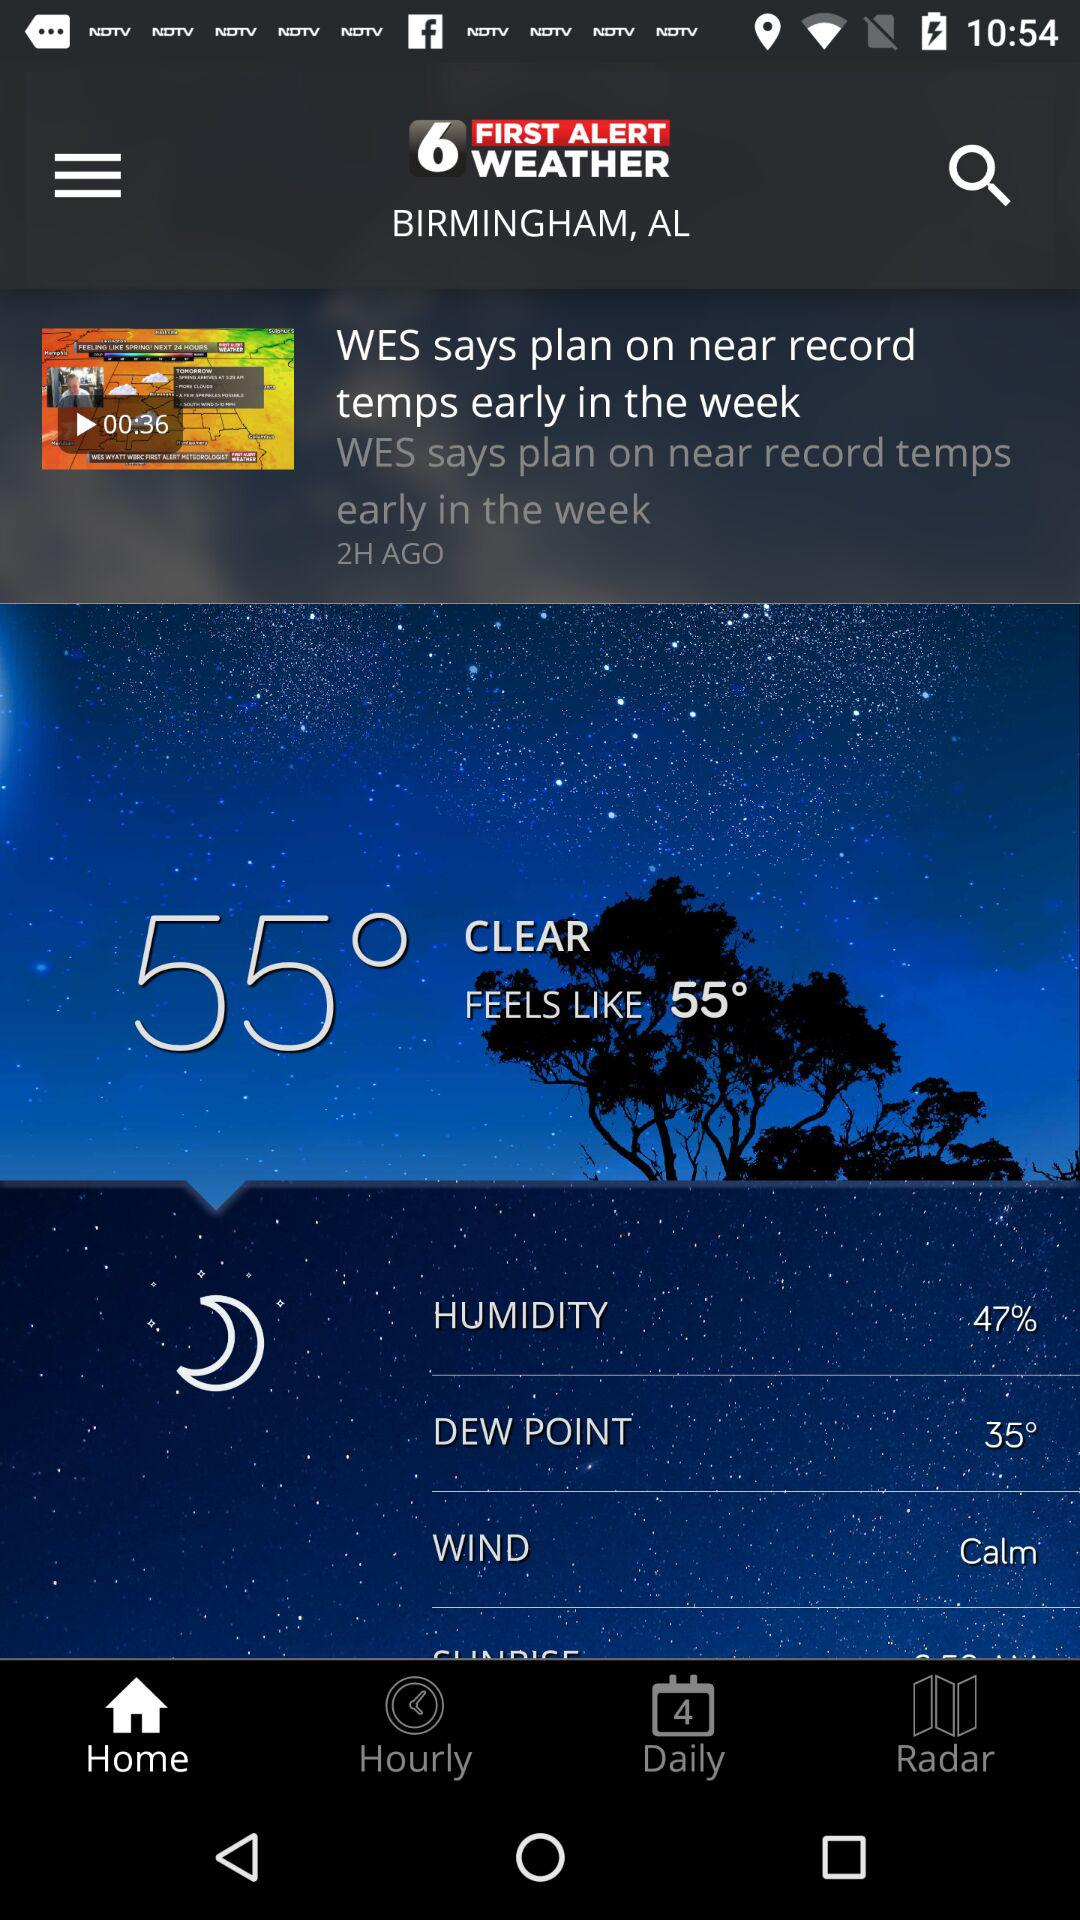How many degrees Fahrenheit is the temperature currently?
Answer the question using a single word or phrase. 55° 